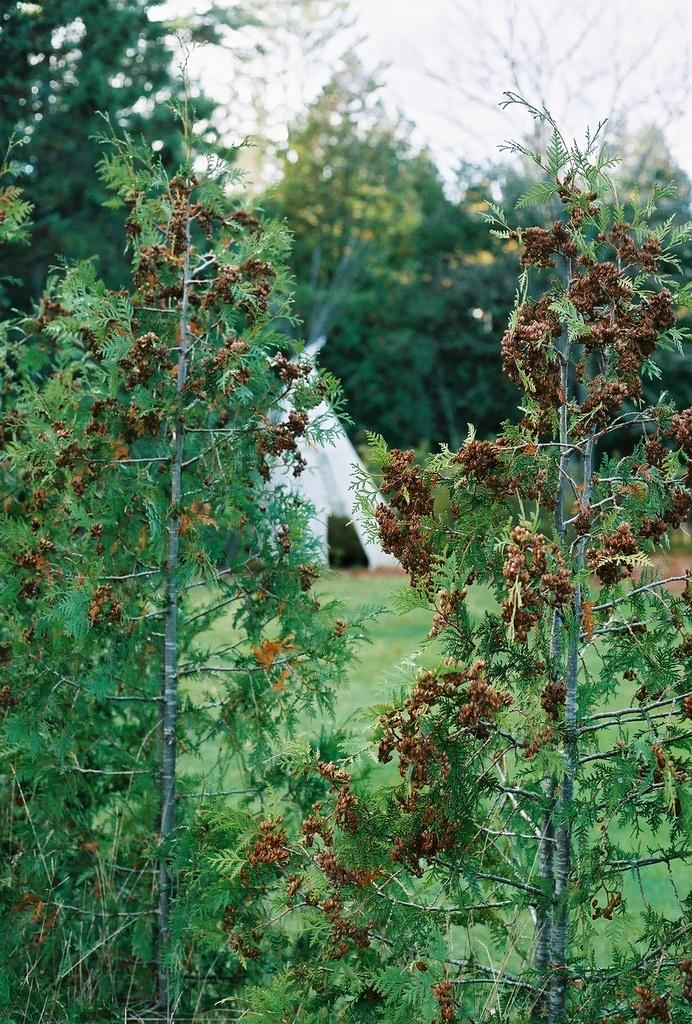What type of plants can be seen in the image? There are plants with flowers in the image. What structure is visible in the background of the image? There is a tent in the background of the image. What type of vegetation is in the background of the image? There are trees in the background of the image. What is visible at the top of the image? The sky is visible at the top of the image. What type of furniture can be seen in the image? There is no furniture present in the image. How many boys are visible in the image? There are no boys present in the image. 